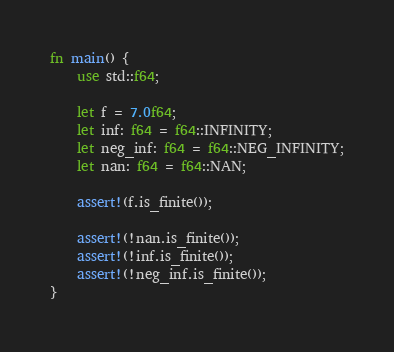Convert code to text. <code><loc_0><loc_0><loc_500><loc_500><_Rust_>fn main() {
    use std::f64;
    
    let f = 7.0f64;
    let inf: f64 = f64::INFINITY;
    let neg_inf: f64 = f64::NEG_INFINITY;
    let nan: f64 = f64::NAN;
    
    assert!(f.is_finite());
    
    assert!(!nan.is_finite());
    assert!(!inf.is_finite());
    assert!(!neg_inf.is_finite());
}
</code> 